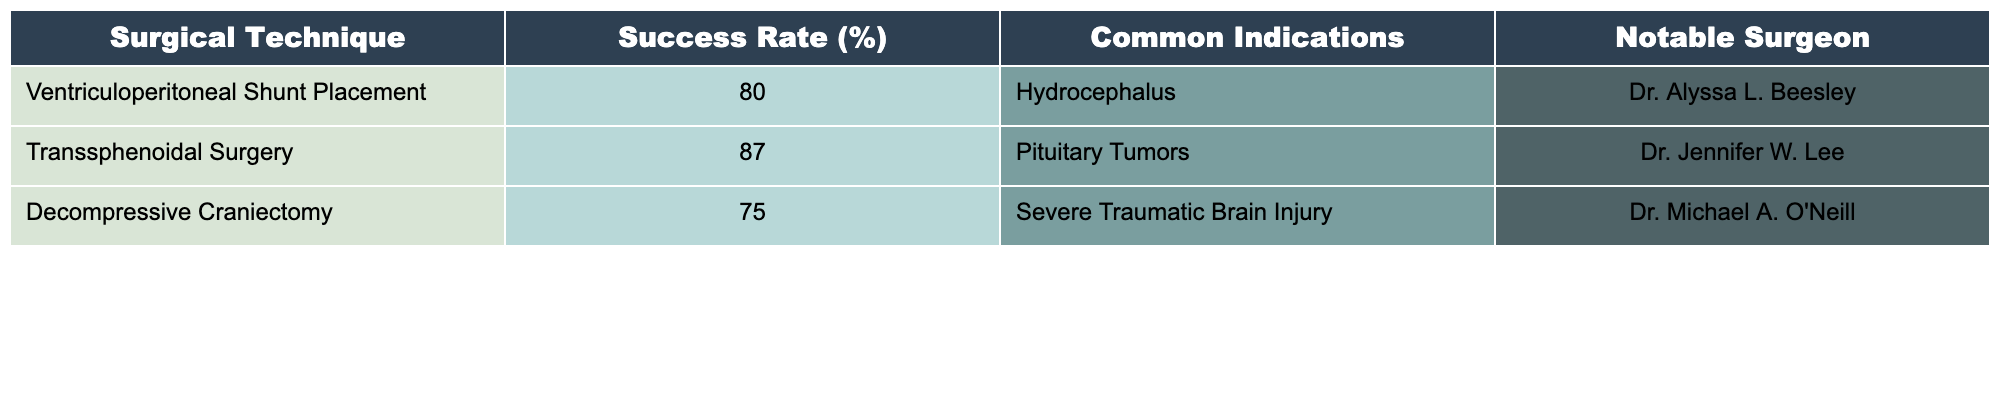What is the success rate of Transsphenoidal Surgery? The table lists the success rate for all surgical techniques. For Transsphenoidal Surgery, the success rate is explicitly stated as 87%.
Answer: 87% Which surgical technique has the lowest success rate? By comparing the success rates listed, Decompressive Craniectomy has the lowest success rate at 75%.
Answer: Decompressive Craniectomy Are there any surgical techniques listed that have a success rate above 80%? A quick review of the success rates shows both Transsphenoidal Surgery (87%) and Ventriculoperitoneal Shunt Placement (80%) exceed 80%.
Answer: Yes What is the average success rate of the listed techniques? The success rates are 80%, 87%, and 75%. Adding these (80 + 87 + 75 = 242) and dividing by the number of techniques (3) gives an average of 80.67%.
Answer: 80.67% Is it true that Hydrocephalus is treated using Transsphenoidal Surgery? The table indicates that Hydrocephalus is associated with Ventriculoperitoneal Shunt Placement, not Transsphenoidal Surgery, making the statement false.
Answer: False What is the difference in success rates between the highest and lowest techniques listed? The highest success rate is 87% for Transsphenoidal Surgery and the lowest is 75% for Decompressive Craniectomy. The difference is 87 - 75 = 12%.
Answer: 12% Which notable surgeon is associated with the technique for treating Pituitary Tumors? The table associates Dr. Jennifer W. Lee with Transsphenoidal Surgery, which is used to treat Pituitary Tumors.
Answer: Dr. Jennifer W. Lee How many surgical techniques listed have a success rate of 80% or higher? Two techniques, Ventriculoperitoneal Shunt Placement and Transsphenoidal Surgery, have success rates of 80% or greater, meeting this criterion.
Answer: 2 